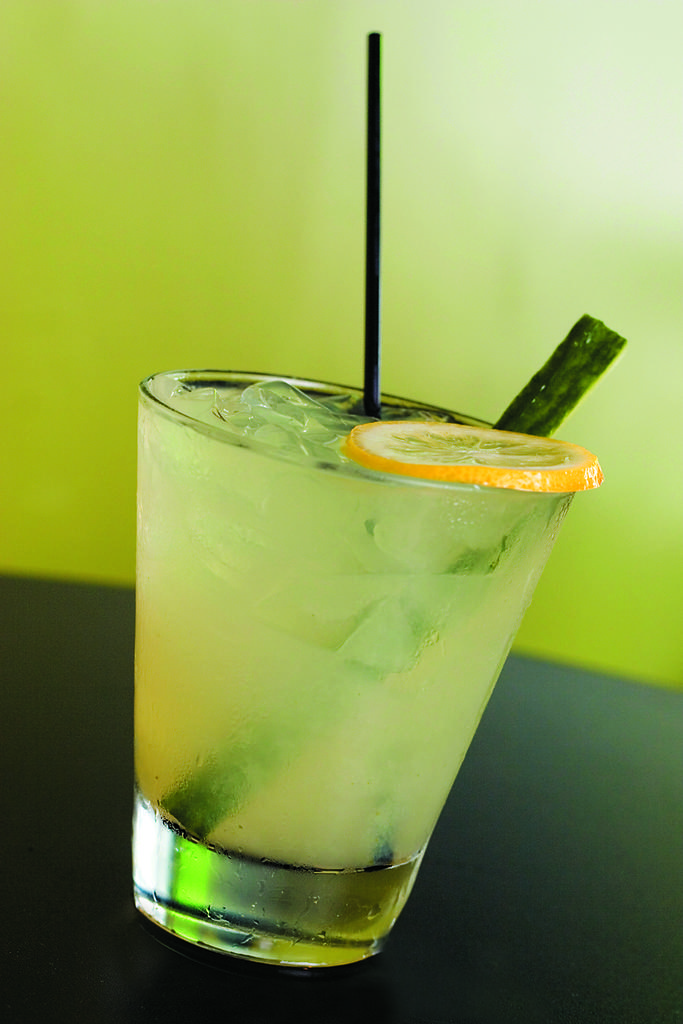What is the main substance in the image? There is a liquid in the image. Are there any additional elements in the liquid? Yes, there are ice cubes in the image. How might someone consume the liquid? There is a straw in the image, which suggests that someone might use it to drink the liquid. What color is the background of the image? The background of the image is green. What type of waste can be seen in the image? There is no waste present in the image; it features a liquid with ice cubes and a straw. What class of object is the liquid contained in? The provided facts do not specify the type of container holding the liquid, so it is impossible to determine the class of object. 